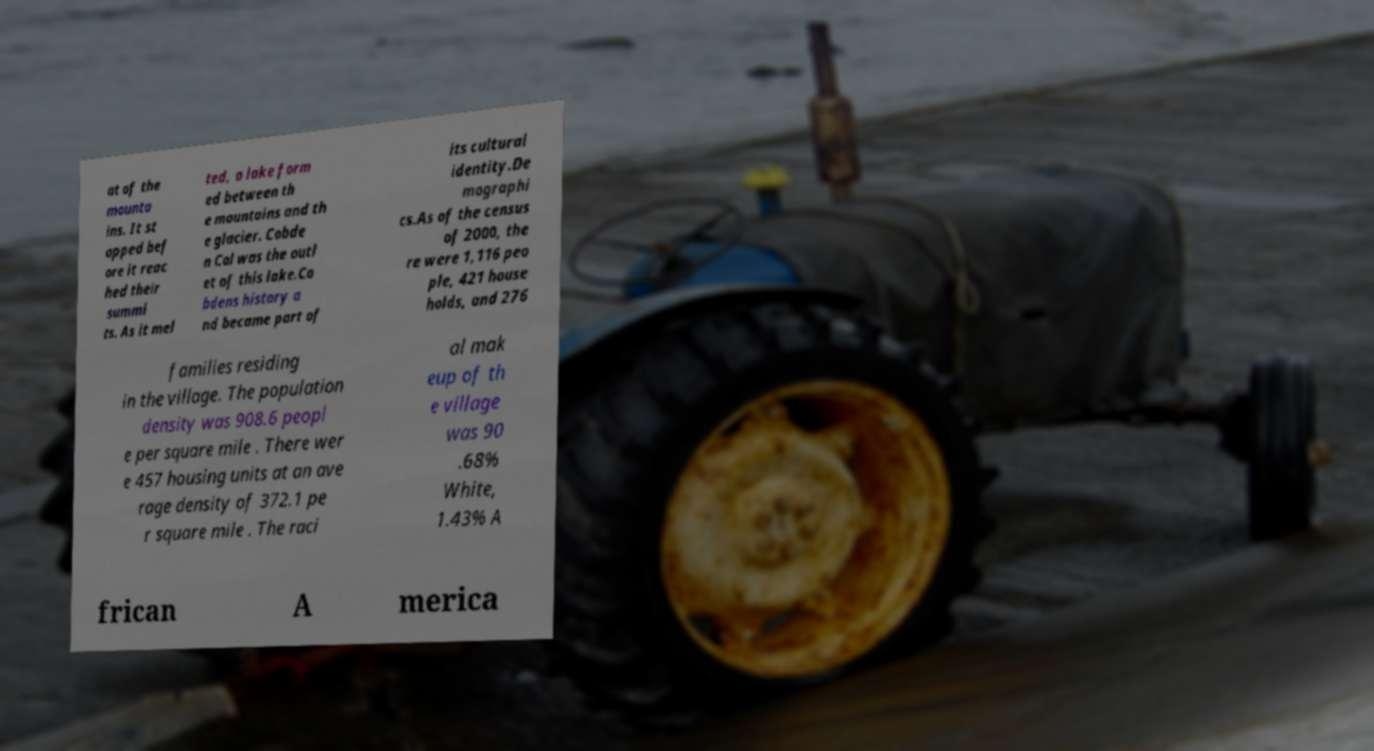I need the written content from this picture converted into text. Can you do that? at of the mounta ins. It st opped bef ore it reac hed their summi ts. As it mel ted, a lake form ed between th e mountains and th e glacier. Cobde n Col was the outl et of this lake.Co bdens history a nd became part of its cultural identity.De mographi cs.As of the census of 2000, the re were 1,116 peo ple, 421 house holds, and 276 families residing in the village. The population density was 908.6 peopl e per square mile . There wer e 457 housing units at an ave rage density of 372.1 pe r square mile . The raci al mak eup of th e village was 90 .68% White, 1.43% A frican A merica 